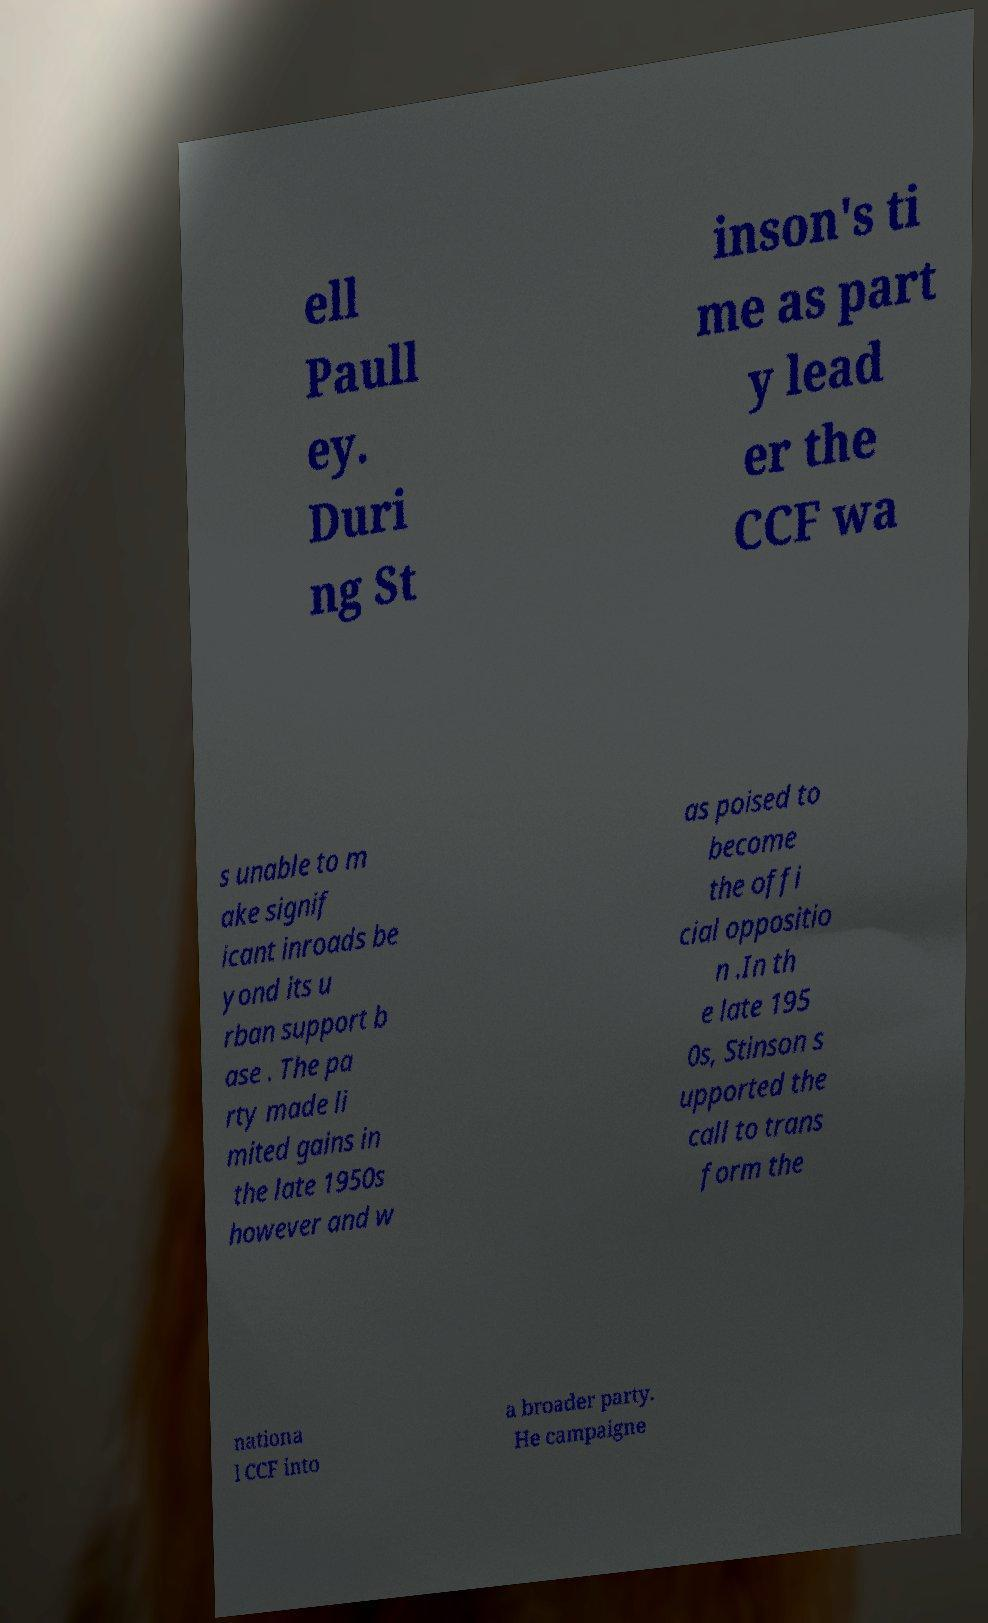Please identify and transcribe the text found in this image. ell Paull ey. Duri ng St inson's ti me as part y lead er the CCF wa s unable to m ake signif icant inroads be yond its u rban support b ase . The pa rty made li mited gains in the late 1950s however and w as poised to become the offi cial oppositio n .In th e late 195 0s, Stinson s upported the call to trans form the nationa l CCF into a broader party. He campaigne 